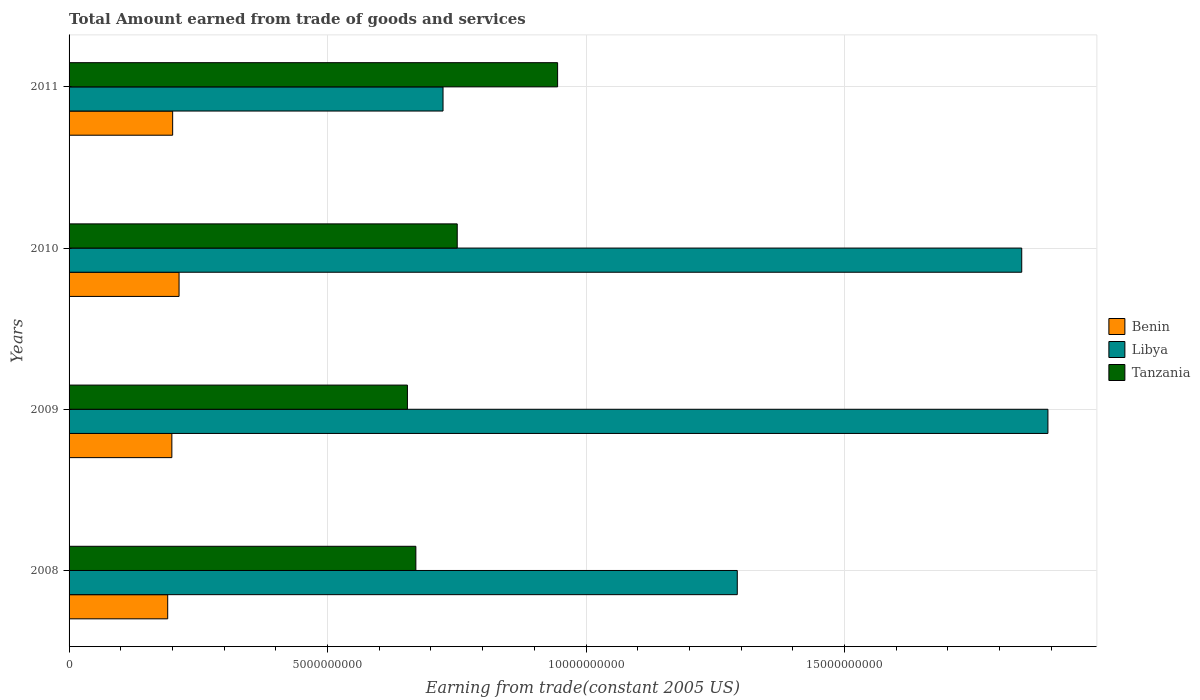How many groups of bars are there?
Ensure brevity in your answer.  4. Are the number of bars per tick equal to the number of legend labels?
Offer a terse response. Yes. How many bars are there on the 2nd tick from the top?
Ensure brevity in your answer.  3. What is the label of the 4th group of bars from the top?
Keep it short and to the point. 2008. What is the total amount earned by trading goods and services in Benin in 2011?
Offer a very short reply. 2.00e+09. Across all years, what is the maximum total amount earned by trading goods and services in Tanzania?
Provide a succinct answer. 9.45e+09. Across all years, what is the minimum total amount earned by trading goods and services in Libya?
Keep it short and to the point. 7.23e+09. In which year was the total amount earned by trading goods and services in Tanzania maximum?
Provide a short and direct response. 2011. In which year was the total amount earned by trading goods and services in Tanzania minimum?
Offer a terse response. 2009. What is the total total amount earned by trading goods and services in Libya in the graph?
Give a very brief answer. 5.75e+1. What is the difference between the total amount earned by trading goods and services in Tanzania in 2009 and that in 2011?
Your answer should be very brief. -2.90e+09. What is the difference between the total amount earned by trading goods and services in Libya in 2010 and the total amount earned by trading goods and services in Benin in 2011?
Offer a very short reply. 1.64e+1. What is the average total amount earned by trading goods and services in Libya per year?
Your answer should be very brief. 1.44e+1. In the year 2011, what is the difference between the total amount earned by trading goods and services in Libya and total amount earned by trading goods and services in Tanzania?
Provide a short and direct response. -2.22e+09. What is the ratio of the total amount earned by trading goods and services in Benin in 2008 to that in 2011?
Your answer should be compact. 0.95. Is the total amount earned by trading goods and services in Tanzania in 2008 less than that in 2011?
Your answer should be very brief. Yes. What is the difference between the highest and the second highest total amount earned by trading goods and services in Tanzania?
Your answer should be compact. 1.94e+09. What is the difference between the highest and the lowest total amount earned by trading goods and services in Libya?
Offer a terse response. 1.17e+1. In how many years, is the total amount earned by trading goods and services in Benin greater than the average total amount earned by trading goods and services in Benin taken over all years?
Provide a short and direct response. 1. What does the 3rd bar from the top in 2008 represents?
Your response must be concise. Benin. What does the 1st bar from the bottom in 2011 represents?
Offer a terse response. Benin. Is it the case that in every year, the sum of the total amount earned by trading goods and services in Libya and total amount earned by trading goods and services in Tanzania is greater than the total amount earned by trading goods and services in Benin?
Keep it short and to the point. Yes. What is the difference between two consecutive major ticks on the X-axis?
Ensure brevity in your answer.  5.00e+09. Are the values on the major ticks of X-axis written in scientific E-notation?
Keep it short and to the point. No. Does the graph contain any zero values?
Ensure brevity in your answer.  No. Does the graph contain grids?
Keep it short and to the point. Yes. How many legend labels are there?
Provide a short and direct response. 3. How are the legend labels stacked?
Make the answer very short. Vertical. What is the title of the graph?
Keep it short and to the point. Total Amount earned from trade of goods and services. What is the label or title of the X-axis?
Offer a very short reply. Earning from trade(constant 2005 US). What is the label or title of the Y-axis?
Your answer should be compact. Years. What is the Earning from trade(constant 2005 US) of Benin in 2008?
Give a very brief answer. 1.91e+09. What is the Earning from trade(constant 2005 US) of Libya in 2008?
Your response must be concise. 1.29e+1. What is the Earning from trade(constant 2005 US) of Tanzania in 2008?
Your answer should be very brief. 6.71e+09. What is the Earning from trade(constant 2005 US) of Benin in 2009?
Provide a succinct answer. 1.99e+09. What is the Earning from trade(constant 2005 US) of Libya in 2009?
Your response must be concise. 1.89e+1. What is the Earning from trade(constant 2005 US) of Tanzania in 2009?
Your response must be concise. 6.54e+09. What is the Earning from trade(constant 2005 US) in Benin in 2010?
Your answer should be compact. 2.13e+09. What is the Earning from trade(constant 2005 US) of Libya in 2010?
Provide a succinct answer. 1.84e+1. What is the Earning from trade(constant 2005 US) in Tanzania in 2010?
Provide a succinct answer. 7.51e+09. What is the Earning from trade(constant 2005 US) of Benin in 2011?
Ensure brevity in your answer.  2.00e+09. What is the Earning from trade(constant 2005 US) of Libya in 2011?
Your answer should be very brief. 7.23e+09. What is the Earning from trade(constant 2005 US) of Tanzania in 2011?
Make the answer very short. 9.45e+09. Across all years, what is the maximum Earning from trade(constant 2005 US) of Benin?
Offer a terse response. 2.13e+09. Across all years, what is the maximum Earning from trade(constant 2005 US) in Libya?
Ensure brevity in your answer.  1.89e+1. Across all years, what is the maximum Earning from trade(constant 2005 US) in Tanzania?
Keep it short and to the point. 9.45e+09. Across all years, what is the minimum Earning from trade(constant 2005 US) in Benin?
Offer a very short reply. 1.91e+09. Across all years, what is the minimum Earning from trade(constant 2005 US) in Libya?
Provide a short and direct response. 7.23e+09. Across all years, what is the minimum Earning from trade(constant 2005 US) in Tanzania?
Ensure brevity in your answer.  6.54e+09. What is the total Earning from trade(constant 2005 US) in Benin in the graph?
Make the answer very short. 8.03e+09. What is the total Earning from trade(constant 2005 US) in Libya in the graph?
Offer a very short reply. 5.75e+1. What is the total Earning from trade(constant 2005 US) in Tanzania in the graph?
Provide a succinct answer. 3.02e+1. What is the difference between the Earning from trade(constant 2005 US) in Benin in 2008 and that in 2009?
Offer a terse response. -8.04e+07. What is the difference between the Earning from trade(constant 2005 US) in Libya in 2008 and that in 2009?
Keep it short and to the point. -6.01e+09. What is the difference between the Earning from trade(constant 2005 US) in Tanzania in 2008 and that in 2009?
Give a very brief answer. 1.63e+08. What is the difference between the Earning from trade(constant 2005 US) in Benin in 2008 and that in 2010?
Make the answer very short. -2.20e+08. What is the difference between the Earning from trade(constant 2005 US) in Libya in 2008 and that in 2010?
Offer a very short reply. -5.50e+09. What is the difference between the Earning from trade(constant 2005 US) of Tanzania in 2008 and that in 2010?
Provide a succinct answer. -8.00e+08. What is the difference between the Earning from trade(constant 2005 US) in Benin in 2008 and that in 2011?
Give a very brief answer. -9.58e+07. What is the difference between the Earning from trade(constant 2005 US) of Libya in 2008 and that in 2011?
Provide a succinct answer. 5.69e+09. What is the difference between the Earning from trade(constant 2005 US) in Tanzania in 2008 and that in 2011?
Make the answer very short. -2.74e+09. What is the difference between the Earning from trade(constant 2005 US) in Benin in 2009 and that in 2010?
Give a very brief answer. -1.39e+08. What is the difference between the Earning from trade(constant 2005 US) in Libya in 2009 and that in 2010?
Keep it short and to the point. 5.07e+08. What is the difference between the Earning from trade(constant 2005 US) in Tanzania in 2009 and that in 2010?
Ensure brevity in your answer.  -9.63e+08. What is the difference between the Earning from trade(constant 2005 US) in Benin in 2009 and that in 2011?
Your response must be concise. -1.54e+07. What is the difference between the Earning from trade(constant 2005 US) in Libya in 2009 and that in 2011?
Your answer should be very brief. 1.17e+1. What is the difference between the Earning from trade(constant 2005 US) in Tanzania in 2009 and that in 2011?
Make the answer very short. -2.90e+09. What is the difference between the Earning from trade(constant 2005 US) of Benin in 2010 and that in 2011?
Offer a very short reply. 1.24e+08. What is the difference between the Earning from trade(constant 2005 US) in Libya in 2010 and that in 2011?
Offer a terse response. 1.12e+1. What is the difference between the Earning from trade(constant 2005 US) in Tanzania in 2010 and that in 2011?
Your answer should be compact. -1.94e+09. What is the difference between the Earning from trade(constant 2005 US) in Benin in 2008 and the Earning from trade(constant 2005 US) in Libya in 2009?
Provide a short and direct response. -1.70e+1. What is the difference between the Earning from trade(constant 2005 US) of Benin in 2008 and the Earning from trade(constant 2005 US) of Tanzania in 2009?
Your answer should be very brief. -4.64e+09. What is the difference between the Earning from trade(constant 2005 US) in Libya in 2008 and the Earning from trade(constant 2005 US) in Tanzania in 2009?
Your answer should be compact. 6.38e+09. What is the difference between the Earning from trade(constant 2005 US) in Benin in 2008 and the Earning from trade(constant 2005 US) in Libya in 2010?
Provide a succinct answer. -1.65e+1. What is the difference between the Earning from trade(constant 2005 US) in Benin in 2008 and the Earning from trade(constant 2005 US) in Tanzania in 2010?
Your answer should be compact. -5.60e+09. What is the difference between the Earning from trade(constant 2005 US) in Libya in 2008 and the Earning from trade(constant 2005 US) in Tanzania in 2010?
Make the answer very short. 5.42e+09. What is the difference between the Earning from trade(constant 2005 US) in Benin in 2008 and the Earning from trade(constant 2005 US) in Libya in 2011?
Provide a short and direct response. -5.33e+09. What is the difference between the Earning from trade(constant 2005 US) in Benin in 2008 and the Earning from trade(constant 2005 US) in Tanzania in 2011?
Your answer should be very brief. -7.54e+09. What is the difference between the Earning from trade(constant 2005 US) in Libya in 2008 and the Earning from trade(constant 2005 US) in Tanzania in 2011?
Provide a succinct answer. 3.48e+09. What is the difference between the Earning from trade(constant 2005 US) of Benin in 2009 and the Earning from trade(constant 2005 US) of Libya in 2010?
Make the answer very short. -1.64e+1. What is the difference between the Earning from trade(constant 2005 US) in Benin in 2009 and the Earning from trade(constant 2005 US) in Tanzania in 2010?
Give a very brief answer. -5.52e+09. What is the difference between the Earning from trade(constant 2005 US) in Libya in 2009 and the Earning from trade(constant 2005 US) in Tanzania in 2010?
Ensure brevity in your answer.  1.14e+1. What is the difference between the Earning from trade(constant 2005 US) of Benin in 2009 and the Earning from trade(constant 2005 US) of Libya in 2011?
Make the answer very short. -5.25e+09. What is the difference between the Earning from trade(constant 2005 US) of Benin in 2009 and the Earning from trade(constant 2005 US) of Tanzania in 2011?
Your answer should be very brief. -7.46e+09. What is the difference between the Earning from trade(constant 2005 US) of Libya in 2009 and the Earning from trade(constant 2005 US) of Tanzania in 2011?
Give a very brief answer. 9.48e+09. What is the difference between the Earning from trade(constant 2005 US) of Benin in 2010 and the Earning from trade(constant 2005 US) of Libya in 2011?
Your answer should be very brief. -5.11e+09. What is the difference between the Earning from trade(constant 2005 US) in Benin in 2010 and the Earning from trade(constant 2005 US) in Tanzania in 2011?
Your response must be concise. -7.32e+09. What is the difference between the Earning from trade(constant 2005 US) in Libya in 2010 and the Earning from trade(constant 2005 US) in Tanzania in 2011?
Your answer should be very brief. 8.98e+09. What is the average Earning from trade(constant 2005 US) of Benin per year?
Make the answer very short. 2.01e+09. What is the average Earning from trade(constant 2005 US) of Libya per year?
Your answer should be very brief. 1.44e+1. What is the average Earning from trade(constant 2005 US) in Tanzania per year?
Provide a succinct answer. 7.55e+09. In the year 2008, what is the difference between the Earning from trade(constant 2005 US) of Benin and Earning from trade(constant 2005 US) of Libya?
Make the answer very short. -1.10e+1. In the year 2008, what is the difference between the Earning from trade(constant 2005 US) in Benin and Earning from trade(constant 2005 US) in Tanzania?
Give a very brief answer. -4.80e+09. In the year 2008, what is the difference between the Earning from trade(constant 2005 US) of Libya and Earning from trade(constant 2005 US) of Tanzania?
Keep it short and to the point. 6.22e+09. In the year 2009, what is the difference between the Earning from trade(constant 2005 US) in Benin and Earning from trade(constant 2005 US) in Libya?
Provide a succinct answer. -1.69e+1. In the year 2009, what is the difference between the Earning from trade(constant 2005 US) of Benin and Earning from trade(constant 2005 US) of Tanzania?
Your answer should be compact. -4.56e+09. In the year 2009, what is the difference between the Earning from trade(constant 2005 US) of Libya and Earning from trade(constant 2005 US) of Tanzania?
Provide a short and direct response. 1.24e+1. In the year 2010, what is the difference between the Earning from trade(constant 2005 US) of Benin and Earning from trade(constant 2005 US) of Libya?
Your response must be concise. -1.63e+1. In the year 2010, what is the difference between the Earning from trade(constant 2005 US) of Benin and Earning from trade(constant 2005 US) of Tanzania?
Your response must be concise. -5.38e+09. In the year 2010, what is the difference between the Earning from trade(constant 2005 US) in Libya and Earning from trade(constant 2005 US) in Tanzania?
Keep it short and to the point. 1.09e+1. In the year 2011, what is the difference between the Earning from trade(constant 2005 US) of Benin and Earning from trade(constant 2005 US) of Libya?
Your answer should be compact. -5.23e+09. In the year 2011, what is the difference between the Earning from trade(constant 2005 US) of Benin and Earning from trade(constant 2005 US) of Tanzania?
Provide a succinct answer. -7.45e+09. In the year 2011, what is the difference between the Earning from trade(constant 2005 US) in Libya and Earning from trade(constant 2005 US) in Tanzania?
Your answer should be very brief. -2.22e+09. What is the ratio of the Earning from trade(constant 2005 US) in Benin in 2008 to that in 2009?
Keep it short and to the point. 0.96. What is the ratio of the Earning from trade(constant 2005 US) in Libya in 2008 to that in 2009?
Offer a terse response. 0.68. What is the ratio of the Earning from trade(constant 2005 US) in Tanzania in 2008 to that in 2009?
Provide a succinct answer. 1.02. What is the ratio of the Earning from trade(constant 2005 US) in Benin in 2008 to that in 2010?
Provide a succinct answer. 0.9. What is the ratio of the Earning from trade(constant 2005 US) of Libya in 2008 to that in 2010?
Provide a succinct answer. 0.7. What is the ratio of the Earning from trade(constant 2005 US) of Tanzania in 2008 to that in 2010?
Provide a short and direct response. 0.89. What is the ratio of the Earning from trade(constant 2005 US) in Benin in 2008 to that in 2011?
Your response must be concise. 0.95. What is the ratio of the Earning from trade(constant 2005 US) of Libya in 2008 to that in 2011?
Make the answer very short. 1.79. What is the ratio of the Earning from trade(constant 2005 US) of Tanzania in 2008 to that in 2011?
Ensure brevity in your answer.  0.71. What is the ratio of the Earning from trade(constant 2005 US) of Benin in 2009 to that in 2010?
Your answer should be compact. 0.93. What is the ratio of the Earning from trade(constant 2005 US) of Libya in 2009 to that in 2010?
Ensure brevity in your answer.  1.03. What is the ratio of the Earning from trade(constant 2005 US) of Tanzania in 2009 to that in 2010?
Your response must be concise. 0.87. What is the ratio of the Earning from trade(constant 2005 US) in Benin in 2009 to that in 2011?
Give a very brief answer. 0.99. What is the ratio of the Earning from trade(constant 2005 US) in Libya in 2009 to that in 2011?
Offer a terse response. 2.62. What is the ratio of the Earning from trade(constant 2005 US) of Tanzania in 2009 to that in 2011?
Your answer should be very brief. 0.69. What is the ratio of the Earning from trade(constant 2005 US) of Benin in 2010 to that in 2011?
Provide a short and direct response. 1.06. What is the ratio of the Earning from trade(constant 2005 US) of Libya in 2010 to that in 2011?
Offer a very short reply. 2.55. What is the ratio of the Earning from trade(constant 2005 US) in Tanzania in 2010 to that in 2011?
Give a very brief answer. 0.79. What is the difference between the highest and the second highest Earning from trade(constant 2005 US) in Benin?
Ensure brevity in your answer.  1.24e+08. What is the difference between the highest and the second highest Earning from trade(constant 2005 US) of Libya?
Your response must be concise. 5.07e+08. What is the difference between the highest and the second highest Earning from trade(constant 2005 US) of Tanzania?
Your answer should be compact. 1.94e+09. What is the difference between the highest and the lowest Earning from trade(constant 2005 US) in Benin?
Ensure brevity in your answer.  2.20e+08. What is the difference between the highest and the lowest Earning from trade(constant 2005 US) in Libya?
Offer a terse response. 1.17e+1. What is the difference between the highest and the lowest Earning from trade(constant 2005 US) of Tanzania?
Make the answer very short. 2.90e+09. 